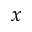Convert formula to latex. <formula><loc_0><loc_0><loc_500><loc_500>x</formula> 